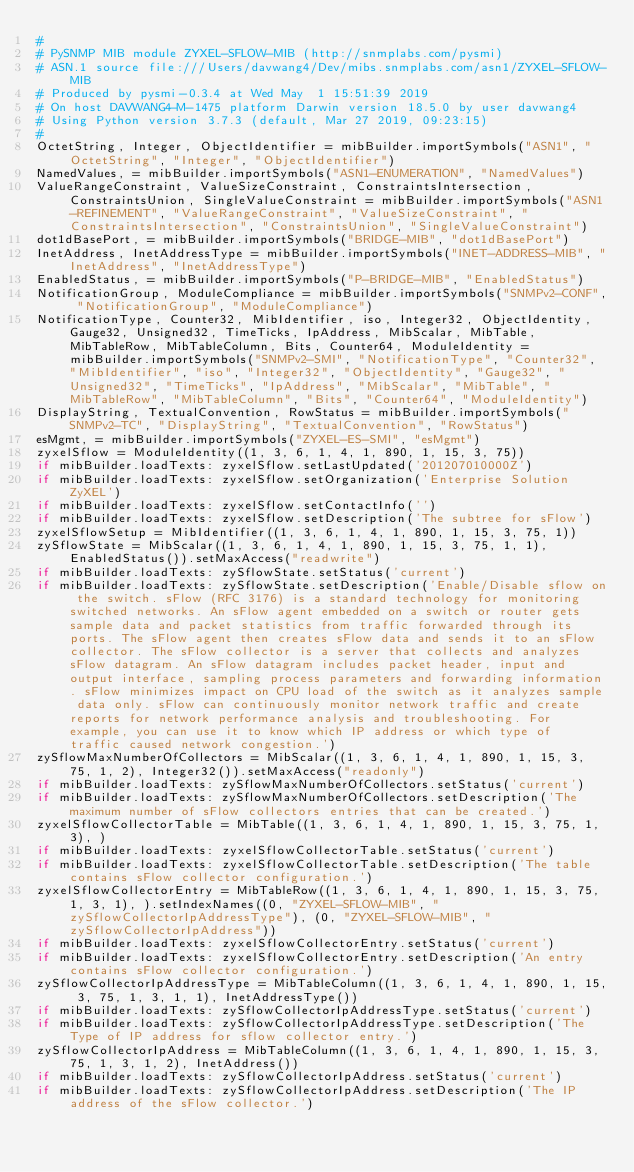Convert code to text. <code><loc_0><loc_0><loc_500><loc_500><_Python_>#
# PySNMP MIB module ZYXEL-SFLOW-MIB (http://snmplabs.com/pysmi)
# ASN.1 source file:///Users/davwang4/Dev/mibs.snmplabs.com/asn1/ZYXEL-SFLOW-MIB
# Produced by pysmi-0.3.4 at Wed May  1 15:51:39 2019
# On host DAVWANG4-M-1475 platform Darwin version 18.5.0 by user davwang4
# Using Python version 3.7.3 (default, Mar 27 2019, 09:23:15) 
#
OctetString, Integer, ObjectIdentifier = mibBuilder.importSymbols("ASN1", "OctetString", "Integer", "ObjectIdentifier")
NamedValues, = mibBuilder.importSymbols("ASN1-ENUMERATION", "NamedValues")
ValueRangeConstraint, ValueSizeConstraint, ConstraintsIntersection, ConstraintsUnion, SingleValueConstraint = mibBuilder.importSymbols("ASN1-REFINEMENT", "ValueRangeConstraint", "ValueSizeConstraint", "ConstraintsIntersection", "ConstraintsUnion", "SingleValueConstraint")
dot1dBasePort, = mibBuilder.importSymbols("BRIDGE-MIB", "dot1dBasePort")
InetAddress, InetAddressType = mibBuilder.importSymbols("INET-ADDRESS-MIB", "InetAddress", "InetAddressType")
EnabledStatus, = mibBuilder.importSymbols("P-BRIDGE-MIB", "EnabledStatus")
NotificationGroup, ModuleCompliance = mibBuilder.importSymbols("SNMPv2-CONF", "NotificationGroup", "ModuleCompliance")
NotificationType, Counter32, MibIdentifier, iso, Integer32, ObjectIdentity, Gauge32, Unsigned32, TimeTicks, IpAddress, MibScalar, MibTable, MibTableRow, MibTableColumn, Bits, Counter64, ModuleIdentity = mibBuilder.importSymbols("SNMPv2-SMI", "NotificationType", "Counter32", "MibIdentifier", "iso", "Integer32", "ObjectIdentity", "Gauge32", "Unsigned32", "TimeTicks", "IpAddress", "MibScalar", "MibTable", "MibTableRow", "MibTableColumn", "Bits", "Counter64", "ModuleIdentity")
DisplayString, TextualConvention, RowStatus = mibBuilder.importSymbols("SNMPv2-TC", "DisplayString", "TextualConvention", "RowStatus")
esMgmt, = mibBuilder.importSymbols("ZYXEL-ES-SMI", "esMgmt")
zyxelSflow = ModuleIdentity((1, 3, 6, 1, 4, 1, 890, 1, 15, 3, 75))
if mibBuilder.loadTexts: zyxelSflow.setLastUpdated('201207010000Z')
if mibBuilder.loadTexts: zyxelSflow.setOrganization('Enterprise Solution ZyXEL')
if mibBuilder.loadTexts: zyxelSflow.setContactInfo('')
if mibBuilder.loadTexts: zyxelSflow.setDescription('The subtree for sFlow')
zyxelSflowSetup = MibIdentifier((1, 3, 6, 1, 4, 1, 890, 1, 15, 3, 75, 1))
zySflowState = MibScalar((1, 3, 6, 1, 4, 1, 890, 1, 15, 3, 75, 1, 1), EnabledStatus()).setMaxAccess("readwrite")
if mibBuilder.loadTexts: zySflowState.setStatus('current')
if mibBuilder.loadTexts: zySflowState.setDescription('Enable/Disable sflow on the switch. sFlow (RFC 3176) is a standard technology for monitoring switched networks. An sFlow agent embedded on a switch or router gets sample data and packet statistics from traffic forwarded through its ports. The sFlow agent then creates sFlow data and sends it to an sFlow collector. The sFlow collector is a server that collects and analyzes sFlow datagram. An sFlow datagram includes packet header, input and output interface, sampling process parameters and forwarding information. sFlow minimizes impact on CPU load of the switch as it analyzes sample data only. sFlow can continuously monitor network traffic and create reports for network performance analysis and troubleshooting. For example, you can use it to know which IP address or which type of traffic caused network congestion.')
zySflowMaxNumberOfCollectors = MibScalar((1, 3, 6, 1, 4, 1, 890, 1, 15, 3, 75, 1, 2), Integer32()).setMaxAccess("readonly")
if mibBuilder.loadTexts: zySflowMaxNumberOfCollectors.setStatus('current')
if mibBuilder.loadTexts: zySflowMaxNumberOfCollectors.setDescription('The maximum number of sFlow collectors entries that can be created.')
zyxelSflowCollectorTable = MibTable((1, 3, 6, 1, 4, 1, 890, 1, 15, 3, 75, 1, 3), )
if mibBuilder.loadTexts: zyxelSflowCollectorTable.setStatus('current')
if mibBuilder.loadTexts: zyxelSflowCollectorTable.setDescription('The table contains sFlow collector configuration.')
zyxelSflowCollectorEntry = MibTableRow((1, 3, 6, 1, 4, 1, 890, 1, 15, 3, 75, 1, 3, 1), ).setIndexNames((0, "ZYXEL-SFLOW-MIB", "zySflowCollectorIpAddressType"), (0, "ZYXEL-SFLOW-MIB", "zySflowCollectorIpAddress"))
if mibBuilder.loadTexts: zyxelSflowCollectorEntry.setStatus('current')
if mibBuilder.loadTexts: zyxelSflowCollectorEntry.setDescription('An entry contains sFlow collector configuration.')
zySflowCollectorIpAddressType = MibTableColumn((1, 3, 6, 1, 4, 1, 890, 1, 15, 3, 75, 1, 3, 1, 1), InetAddressType())
if mibBuilder.loadTexts: zySflowCollectorIpAddressType.setStatus('current')
if mibBuilder.loadTexts: zySflowCollectorIpAddressType.setDescription('The Type of IP address for sflow collector entry.')
zySflowCollectorIpAddress = MibTableColumn((1, 3, 6, 1, 4, 1, 890, 1, 15, 3, 75, 1, 3, 1, 2), InetAddress())
if mibBuilder.loadTexts: zySflowCollectorIpAddress.setStatus('current')
if mibBuilder.loadTexts: zySflowCollectorIpAddress.setDescription('The IP address of the sFlow collector.')</code> 